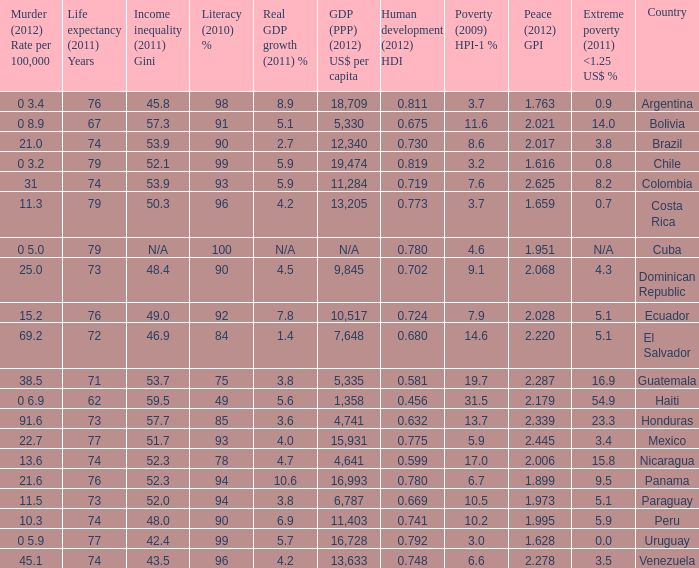What murder (2012) rate per 100,00 also has a 1.616 as the peace (2012) GPI? 0 3.2. 